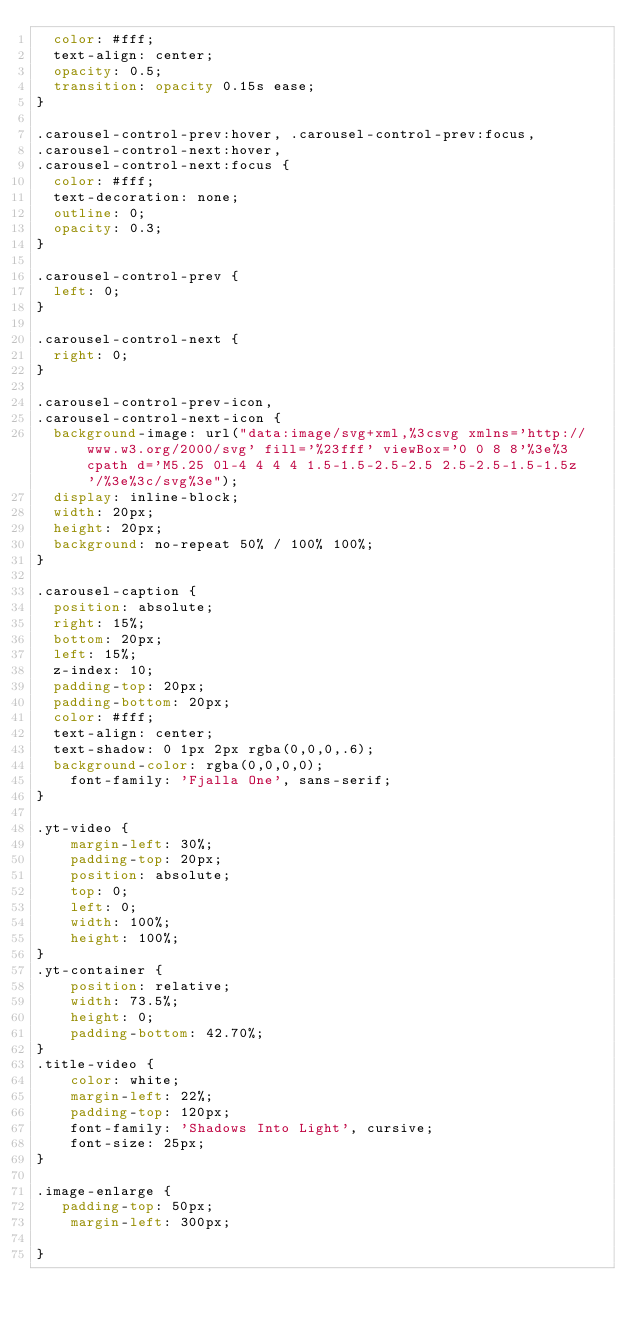Convert code to text. <code><loc_0><loc_0><loc_500><loc_500><_CSS_>  color: #fff;
  text-align: center;
  opacity: 0.5;
  transition: opacity 0.15s ease;
}

.carousel-control-prev:hover, .carousel-control-prev:focus,
.carousel-control-next:hover,
.carousel-control-next:focus {
  color: #fff;
  text-decoration: none;
  outline: 0;
  opacity: 0.3;
}

.carousel-control-prev {
  left: 0;
}

.carousel-control-next {
  right: 0;
}

.carousel-control-prev-icon,
.carousel-control-next-icon {
  background-image: url("data:image/svg+xml,%3csvg xmlns='http://www.w3.org/2000/svg' fill='%23fff' viewBox='0 0 8 8'%3e%3cpath d='M5.25 0l-4 4 4 4 1.5-1.5-2.5-2.5 2.5-2.5-1.5-1.5z'/%3e%3c/svg%3e");
  display: inline-block;
  width: 20px;
  height: 20px;
  background: no-repeat 50% / 100% 100%;
}

.carousel-caption {
  position: absolute;
  right: 15%;
  bottom: 20px;
  left: 15%;
  z-index: 10;
  padding-top: 20px;
  padding-bottom: 20px;
  color: #fff;
  text-align: center;
  text-shadow: 0 1px 2px rgba(0,0,0,.6);
  background-color: rgba(0,0,0,0);
    font-family: 'Fjalla One', sans-serif;
}

.yt-video {
    margin-left: 30%;
    padding-top: 20px;
    position: absolute;
    top: 0;
    left: 0;
    width: 100%;
    height: 100%;
}
.yt-container {
    position: relative;
    width: 73.5%;
    height: 0;
    padding-bottom: 42.70%;
}
.title-video {
    color: white;
    margin-left: 22%;
    padding-top: 120px;
    font-family: 'Shadows Into Light', cursive;
    font-size: 25px;
}

.image-enlarge {
   padding-top: 50px;
    margin-left: 300px;

}
</code> 